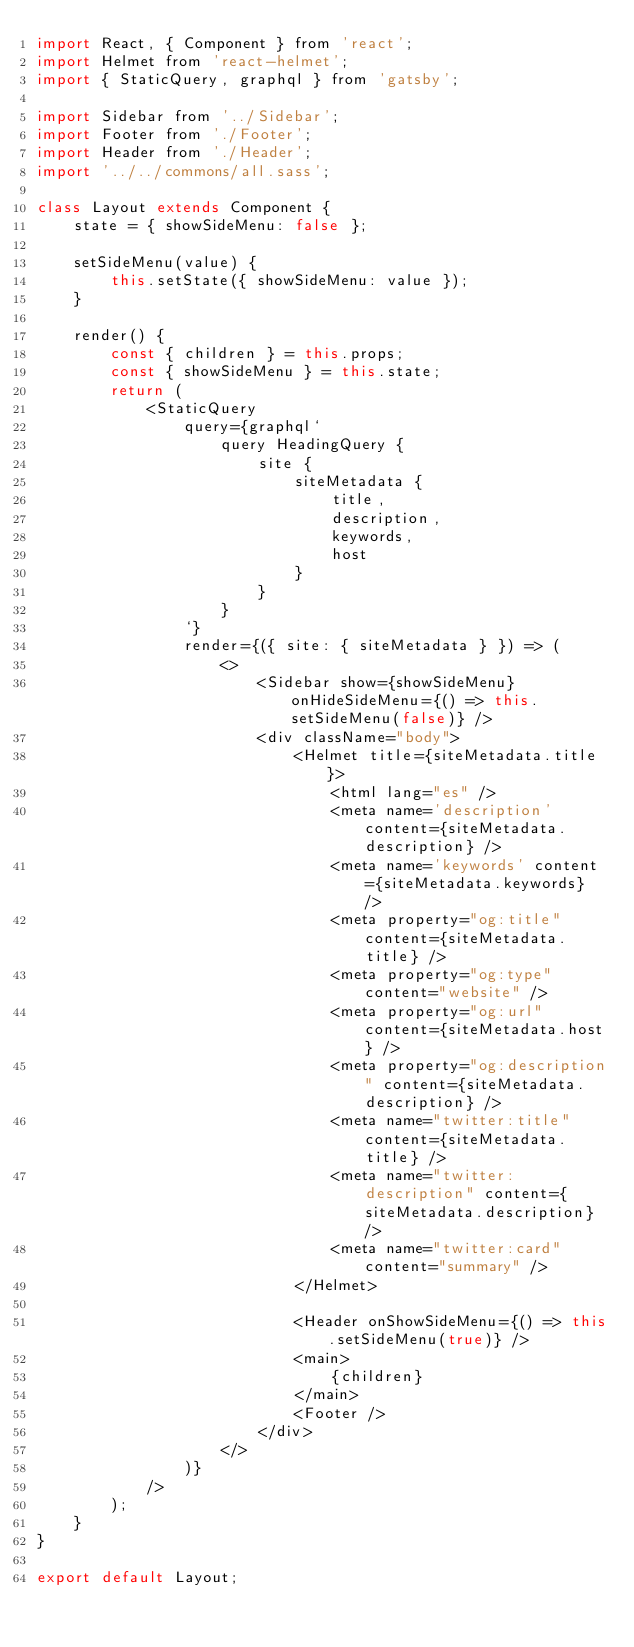Convert code to text. <code><loc_0><loc_0><loc_500><loc_500><_JavaScript_>import React, { Component } from 'react';
import Helmet from 'react-helmet';
import { StaticQuery, graphql } from 'gatsby';

import Sidebar from '../Sidebar';
import Footer from './Footer';
import Header from './Header';
import '../../commons/all.sass';

class Layout extends Component {
    state = { showSideMenu: false };

    setSideMenu(value) {
        this.setState({ showSideMenu: value });
    }

    render() {
        const { children } = this.props;
        const { showSideMenu } = this.state;
        return (
            <StaticQuery
                query={graphql`
                    query HeadingQuery {
                        site {
                            siteMetadata {
                                title,
                                description,
                                keywords,
                                host
                            }
                        }
                    }
                `}
                render={({ site: { siteMetadata } }) => (
                    <>
                        <Sidebar show={showSideMenu} onHideSideMenu={() => this.setSideMenu(false)} />
                        <div className="body">
                            <Helmet title={siteMetadata.title}>
                                <html lang="es" />
                                <meta name='description' content={siteMetadata.description} />
                                <meta name='keywords' content={siteMetadata.keywords} />
                                <meta property="og:title" content={siteMetadata.title} />
                                <meta property="og:type" content="website" />
                                <meta property="og:url" content={siteMetadata.host} />
                                <meta property="og:description" content={siteMetadata.description} />
                                <meta name="twitter:title" content={siteMetadata.title} />
                                <meta name="twitter:description" content={siteMetadata.description} />
                                <meta name="twitter:card" content="summary" />
                            </Helmet>

                            <Header onShowSideMenu={() => this.setSideMenu(true)} />
                            <main>
                                {children}
                            </main>
                            <Footer />
                        </div>
                    </>
                )}
            />
        );
    }
}

export default Layout;
</code> 